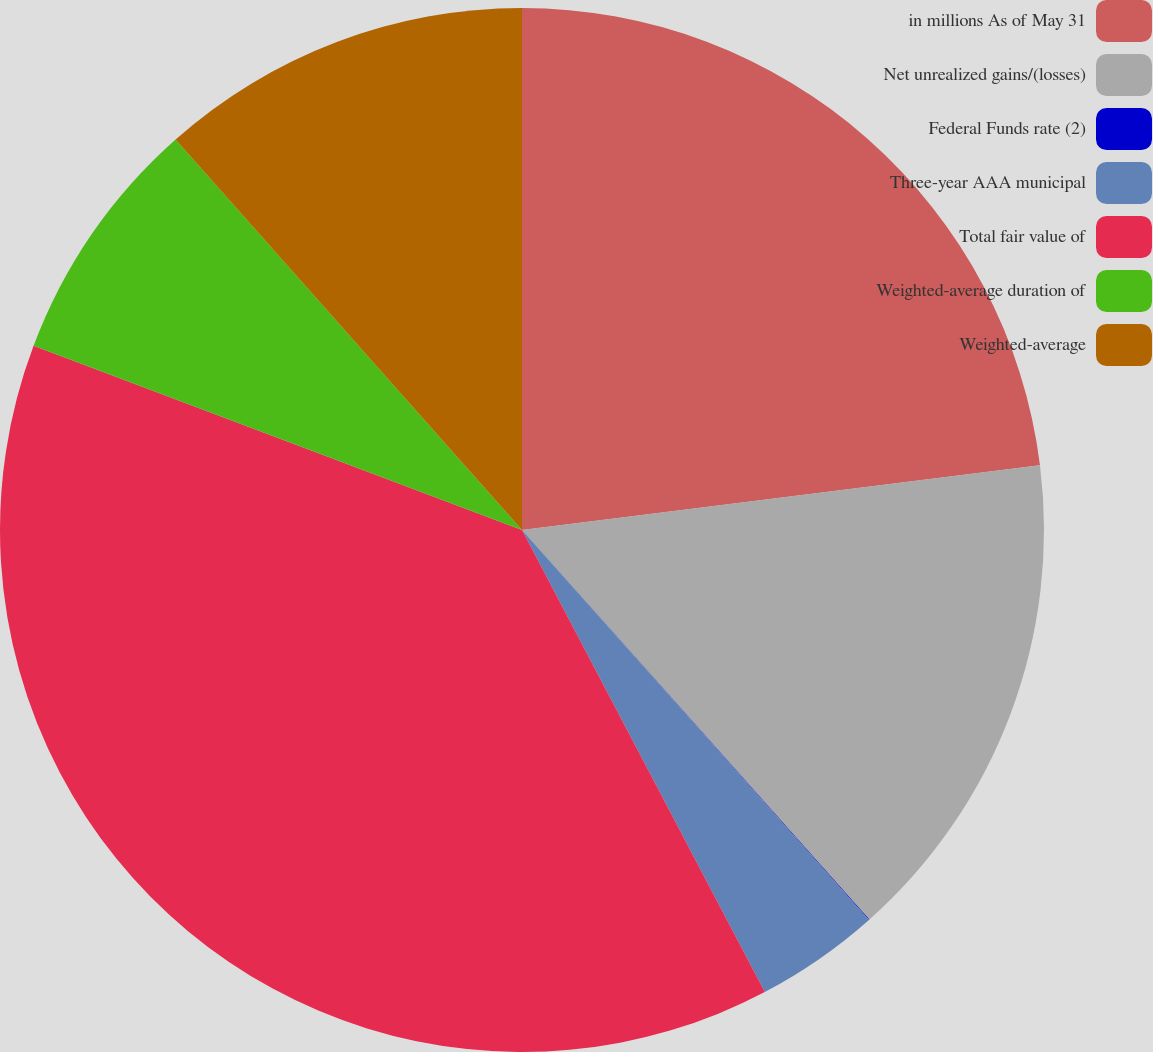<chart> <loc_0><loc_0><loc_500><loc_500><pie_chart><fcel>in millions As of May 31<fcel>Net unrealized gains/(losses)<fcel>Federal Funds rate (2)<fcel>Three-year AAA municipal<fcel>Total fair value of<fcel>Weighted-average duration of<fcel>Weighted-average<nl><fcel>23.02%<fcel>15.39%<fcel>0.02%<fcel>3.87%<fcel>38.44%<fcel>7.71%<fcel>11.55%<nl></chart> 